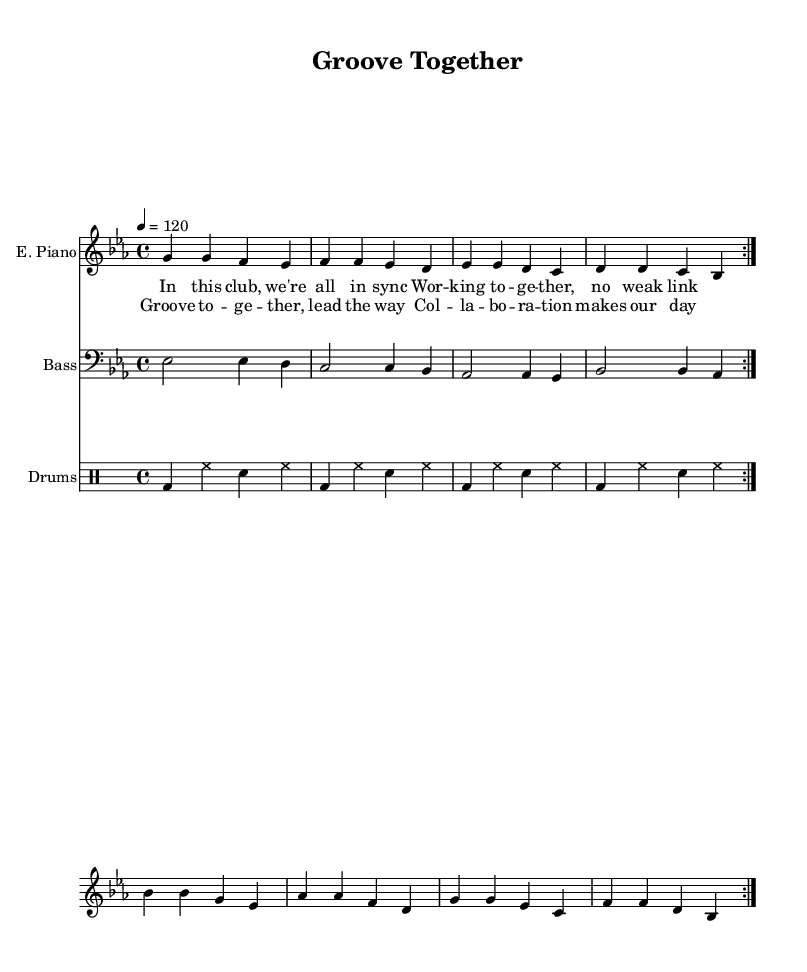What is the key signature of this music? The key signature is indicated at the beginning of the staff, which shows one flat, indicating that the piece is in E flat major.
Answer: E flat major What is the time signature of this piece? The time signature can be found at the beginning of the score, where it indicates four beats per measure, denoted by 4/4.
Answer: 4/4 What is the tempo marking for this piece? The tempo is given below the clef in the score, which indicates that the speed is set at 120 beats per minute.
Answer: 120 How many measures are there in the main motif? By counting each distinct group of notes in the repeated sections, we find that there are eight measures in the electric piano and bass parts before they repeat.
Answer: Eight What musical form does this song primarily follow? The piece is organized in a structure that suggests repetition of sections, specifically verses followed by a chorus, typical of disco music focusing on collaboration and groove.
Answer: Verse-Chorus What does the drum pattern suggest about the style of this piece? The repeating bass drum with snare and hi-hat creates a consistent dance rhythm, typical in disco music, reflecting an upbeat and collaborative atmosphere.
Answer: Dance rhythm What does the lyric focus on in this piece? The lyrics emphasize themes of collaboration and teamwork, specifically expressing how members are in sync and working together effectively.
Answer: Collaboration 